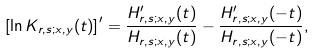<formula> <loc_0><loc_0><loc_500><loc_500>\left [ \ln K _ { r , s ; x , y } ( t ) \right ] ^ { \prime } = \frac { H _ { r , s ; x , y } ^ { \prime } ( t ) } { H _ { r , s ; x , y } ( t ) } - \frac { H _ { r , s ; x , y } ^ { \prime } ( - t ) } { H _ { r , s ; x , y } ( - t ) } , \\</formula> 